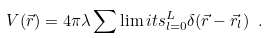<formula> <loc_0><loc_0><loc_500><loc_500>V ( \vec { r } ) = 4 \pi \lambda \sum \lim i t s _ { l = 0 } ^ { L } \delta ( \vec { r } - \vec { r } _ { l } ) \ .</formula> 